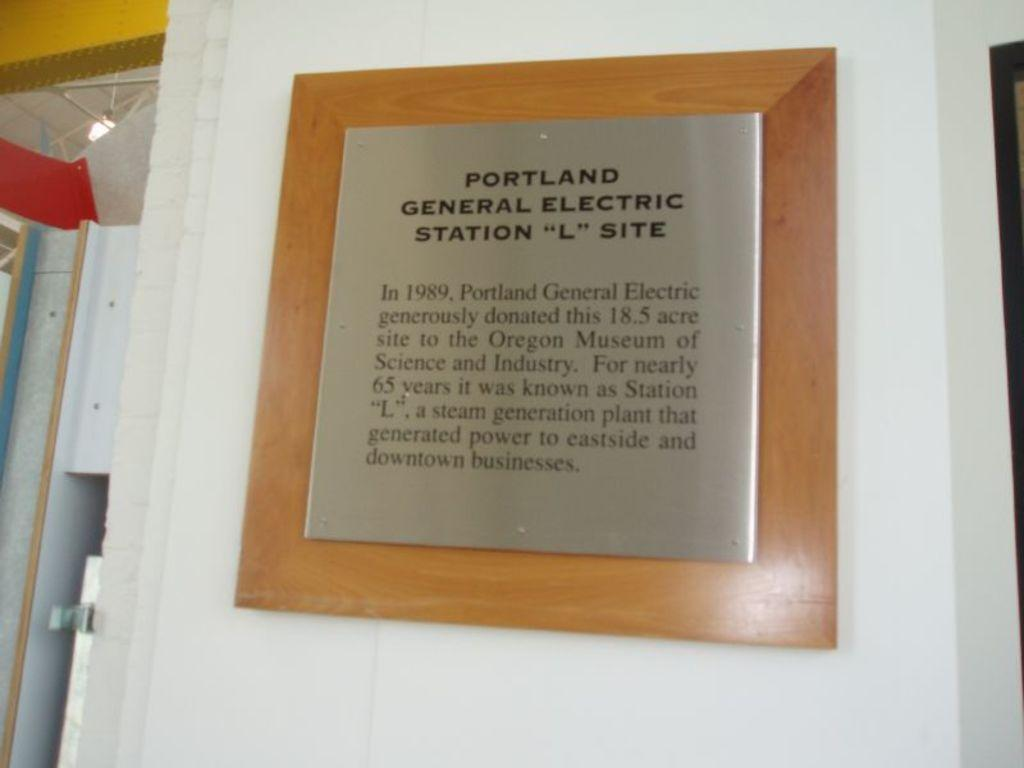What is on the wall in the image? There is a board with text on the wall. What can be seen on the left side of the image? There are objects on the left side of the image. What type of lighting is present in the image? There is a light on the ceiling. What type of voice can be heard coming from the board in the image? There is no voice present in the image; it only features a board with text. What type of quartz is visible on the board in the image? There is no quartz present in the image; it only features a board with text. 